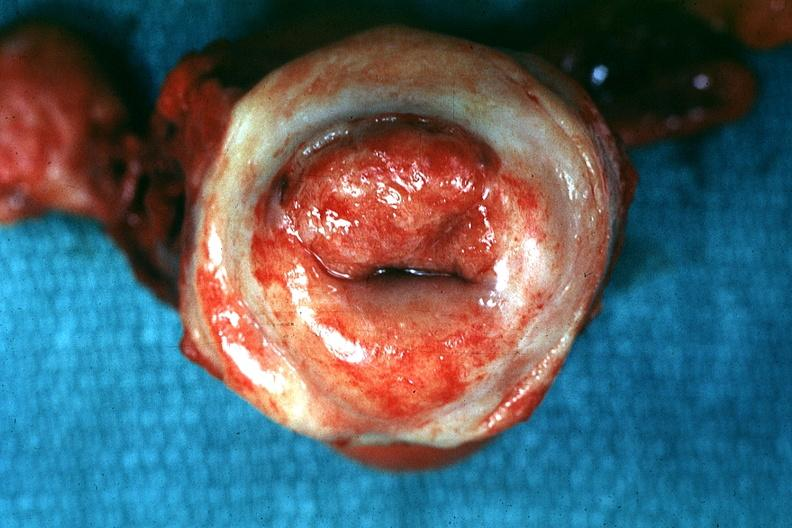what is present?
Answer the question using a single word or phrase. Cervical carcinoma 